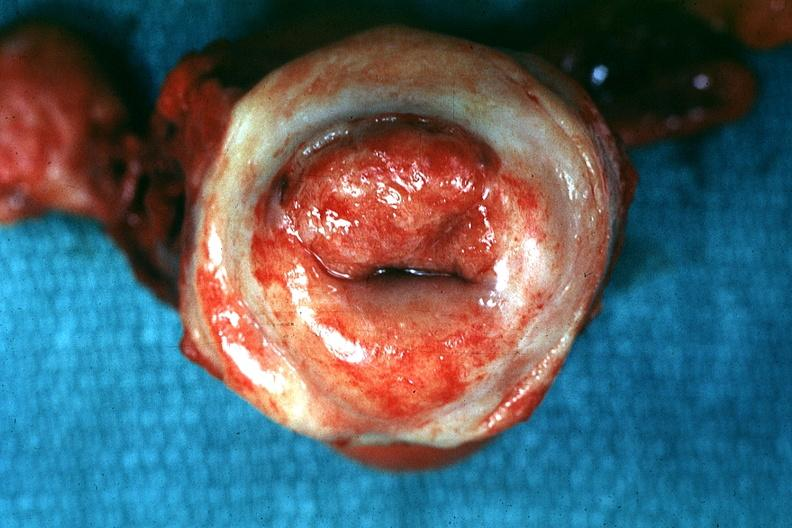what is present?
Answer the question using a single word or phrase. Cervical carcinoma 